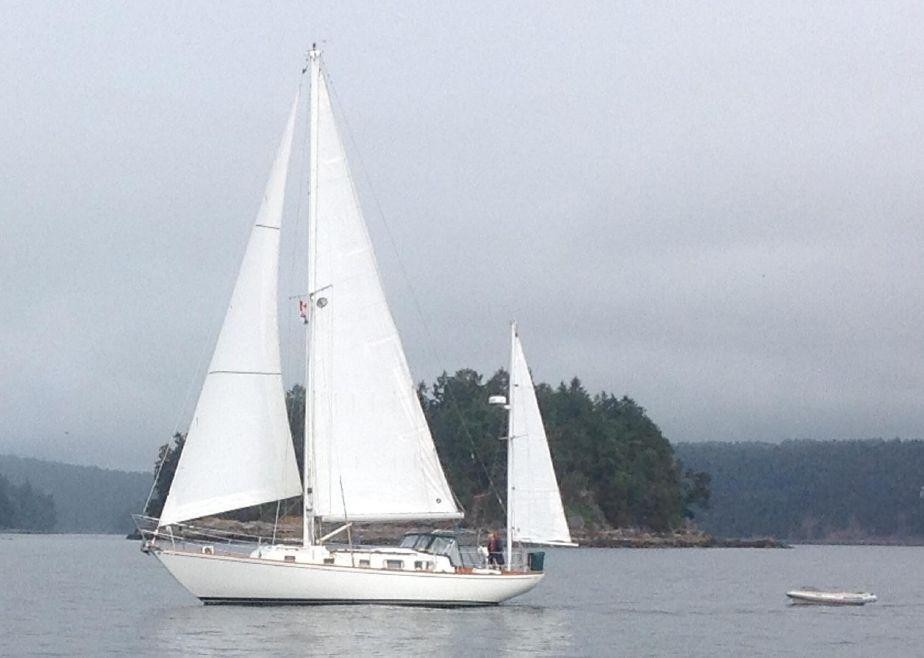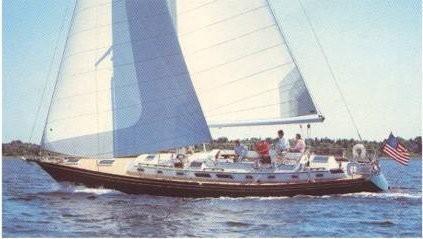The first image is the image on the left, the second image is the image on the right. Given the left and right images, does the statement "One of the boats has three opened sails." hold true? Answer yes or no. Yes. 